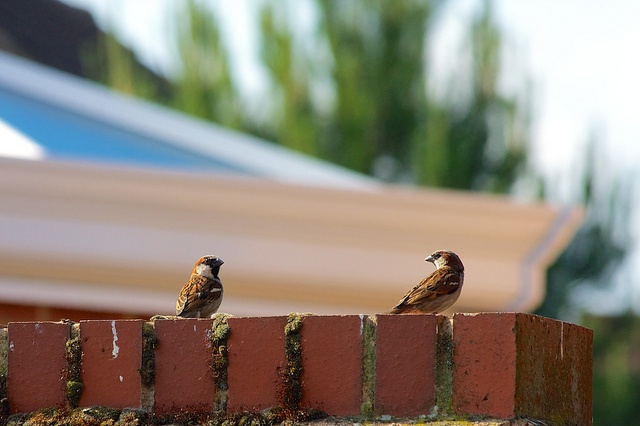Describe the objects in this image and their specific colors. I can see bird in black, maroon, and tan tones and bird in black, maroon, and gray tones in this image. 